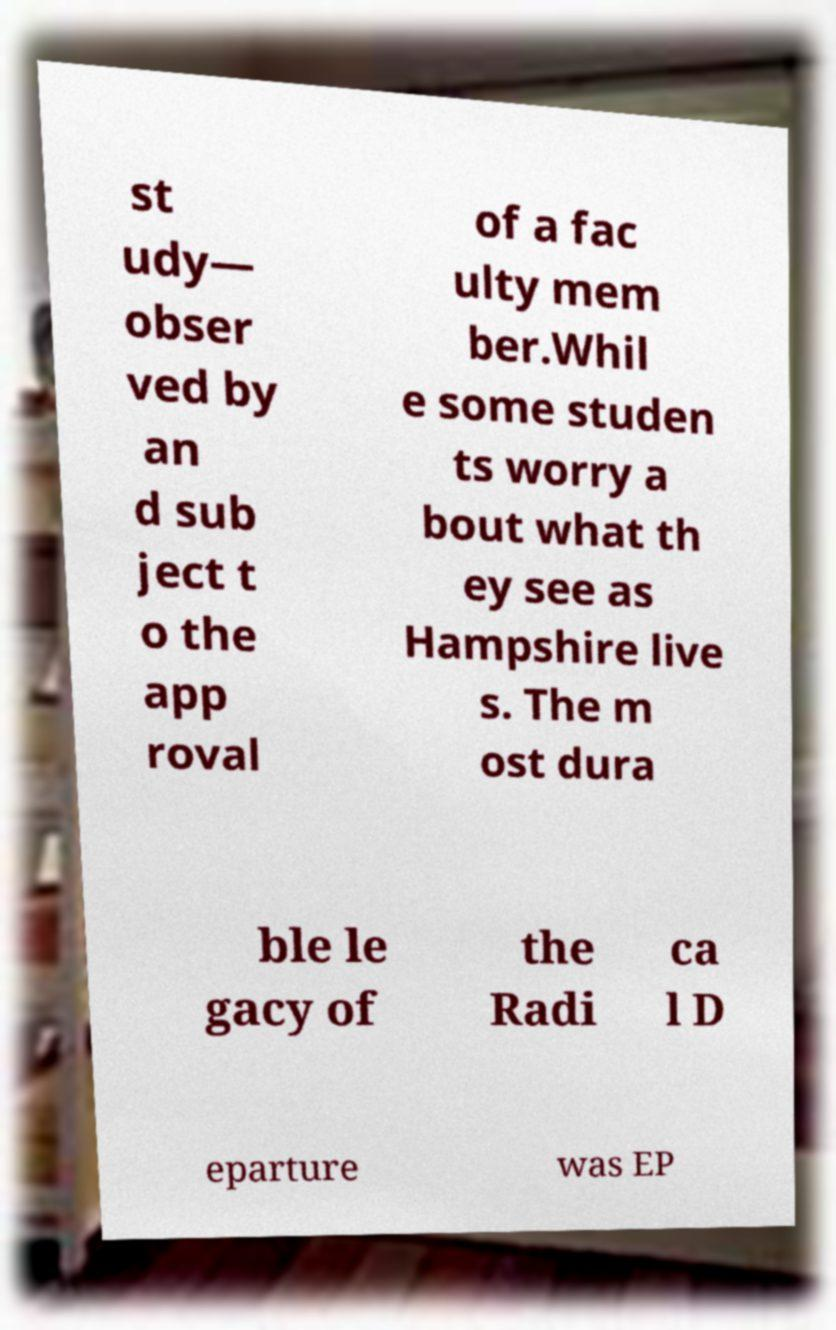Can you read and provide the text displayed in the image?This photo seems to have some interesting text. Can you extract and type it out for me? st udy— obser ved by an d sub ject t o the app roval of a fac ulty mem ber.Whil e some studen ts worry a bout what th ey see as Hampshire live s. The m ost dura ble le gacy of the Radi ca l D eparture was EP 